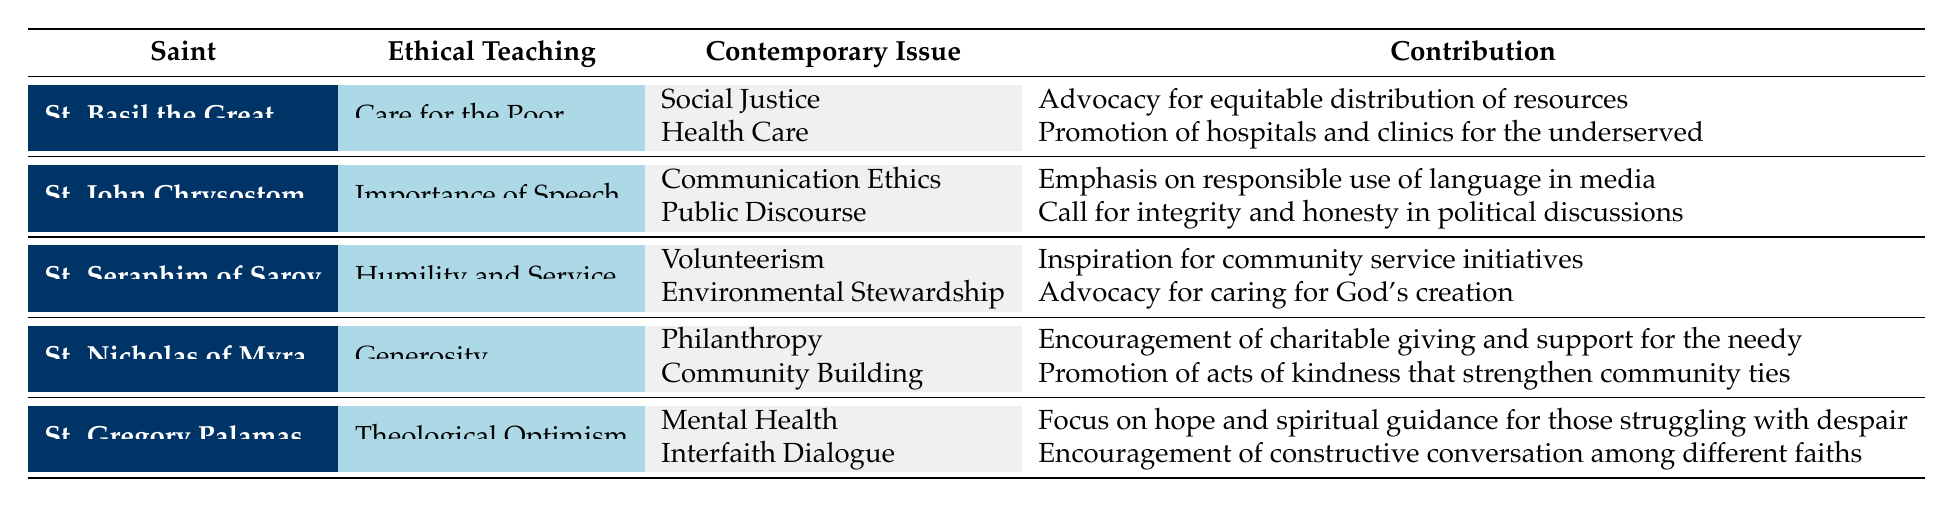What ethical teaching is associated with St. Nicholas of Myra? The table states that St. Nicholas of Myra is associated with the ethical teaching of "Generosity."
Answer: Generosity Which saint advocated for mental health through hope and spiritual guidance? St. Gregory Palamas is mentioned in the table as advocating for mental health by focusing on hope and spiritual guidance for those struggling with despair.
Answer: St. Gregory Palamas How many contemporary applications are listed for St. Basil the Great? According to the table, St. Basil the Great has two contemporary applications: one related to social justice and another related to health care.
Answer: Two Is St. Seraphim of Sarov associated with the issue of Environmental Stewardship? Yes, the table shows that St. Seraphim of Sarov is associated with Environmental Stewardship as part of his ethical teaching on humility and service.
Answer: Yes Who emphasizes the responsible use of language in media? St. John Chrysostom is noted in the table for emphasizing the responsible use of language in media, linked to his ethical teaching on the importance of speech.
Answer: St. John Chrysostom Which saint's contributions include promoting acts of kindness? The table indicates that St. Nicholas of Myra promotes acts of kindness that strengthen community ties as part of his contribution to community building.
Answer: St. Nicholas of Myra What is the contribution of St. Basil the Great concerning health care? St. Basil the Great's contribution concerning health care is described in the table as "Promotion of hospitals and clinics for the underserved."
Answer: Promotion of hospitals and clinics for the underserved Which saint is connected to both interfaith dialogue and mental health? The table lists St. Gregory Palamas as connected to interfaith dialogue and also addressing mental health, making him the answer to this query.
Answer: St. Gregory Palamas Calculate the total number of distinct contemporary issues addressed by all the saints in the table. Each saint presented in the table contributes to two contemporary issues. With five saints, the total number of distinct contemporary issues addressed is 2 (issues per saint) times 5 (saints) equals 10.
Answer: 10 Does St. Basil the Great focus on environmental advocacy? No, St. Basil the Great is focused on care for the poor, specifically through social justice and health care, not directly on environmental advocacy as per the table.
Answer: No 